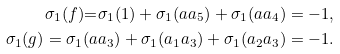Convert formula to latex. <formula><loc_0><loc_0><loc_500><loc_500>\sigma _ { 1 } ( f ) { = } \sigma _ { 1 } ( 1 ) + \sigma _ { 1 } ( a a _ { 5 } ) + \sigma _ { 1 } ( a a _ { 4 } ) = - 1 , \\ \sigma _ { 1 } ( g ) = \sigma _ { 1 } ( a a _ { 3 } ) + \sigma _ { 1 } ( a _ { 1 } a _ { 3 } ) + \sigma _ { 1 } ( a _ { 2 } a _ { 3 } ) = - 1 .</formula> 